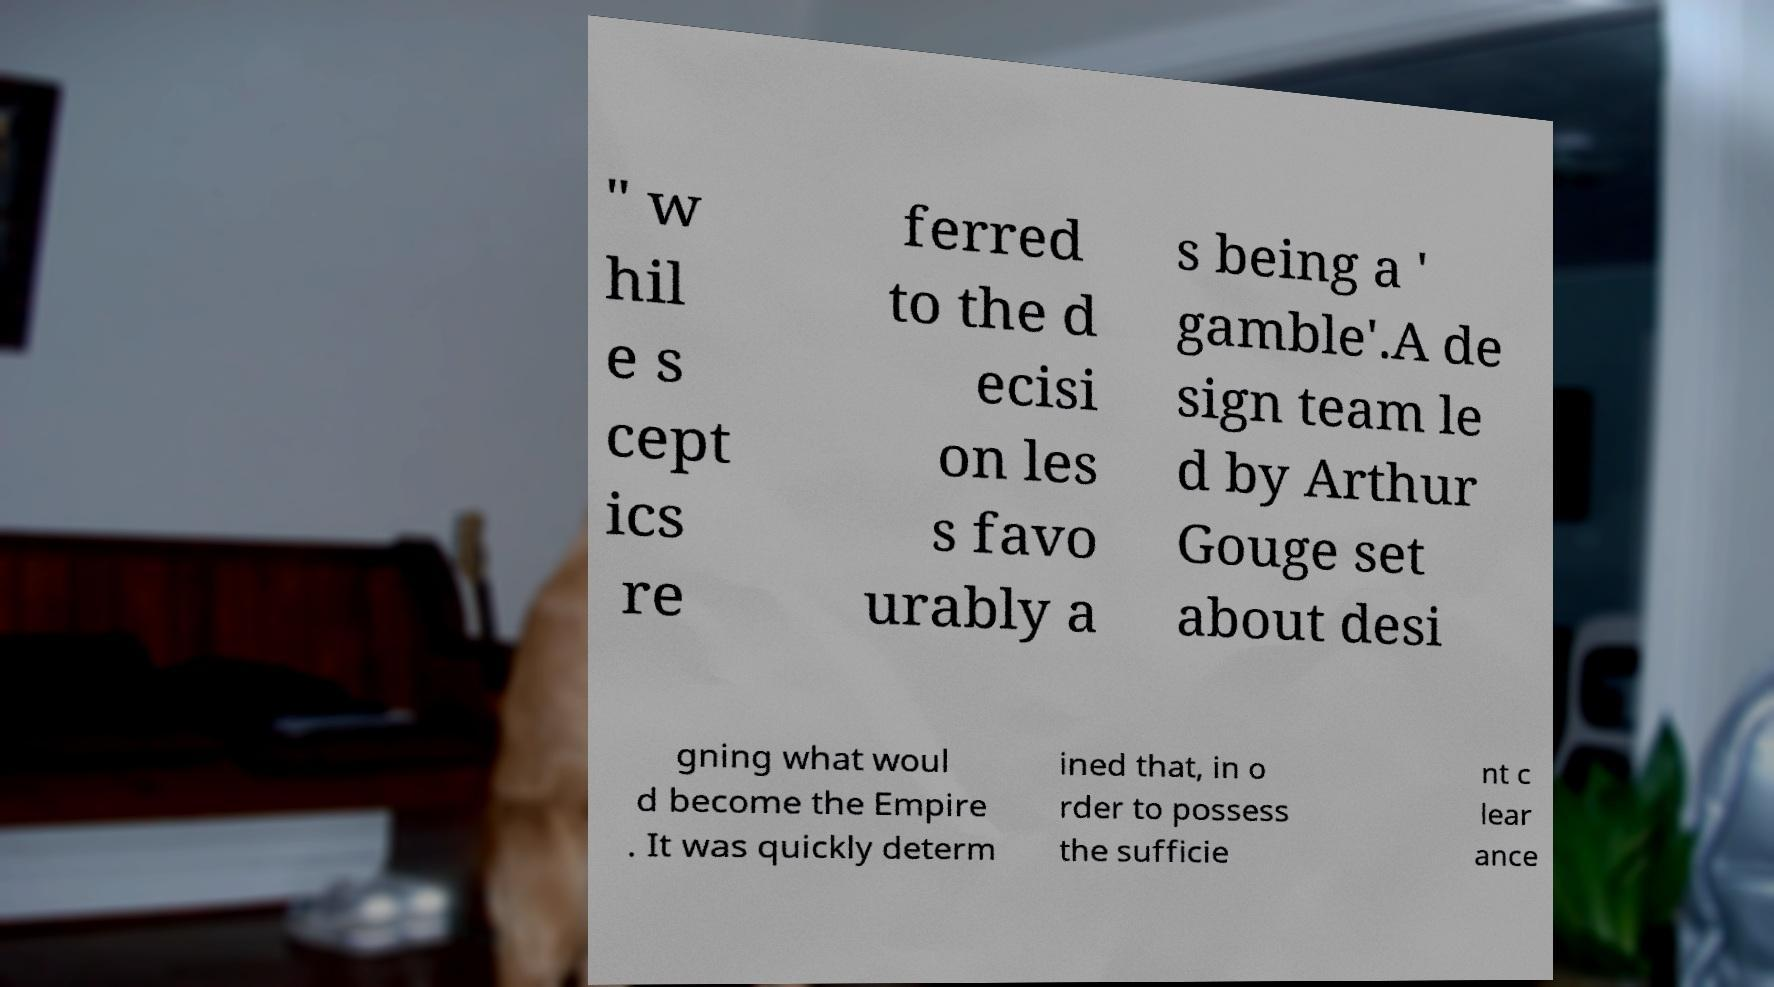Can you accurately transcribe the text from the provided image for me? " w hil e s cept ics re ferred to the d ecisi on les s favo urably a s being a ' gamble'.A de sign team le d by Arthur Gouge set about desi gning what woul d become the Empire . It was quickly determ ined that, in o rder to possess the sufficie nt c lear ance 